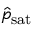Convert formula to latex. <formula><loc_0><loc_0><loc_500><loc_500>\hat { p } _ { s a t }</formula> 